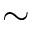Convert formula to latex. <formula><loc_0><loc_0><loc_500><loc_500>\sim</formula> 